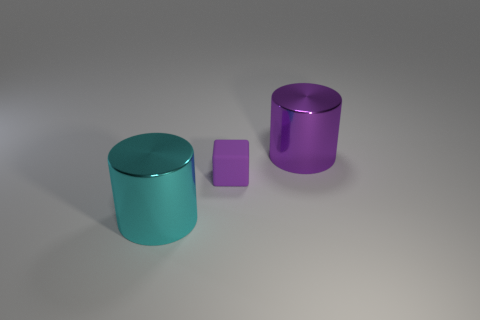Is there anything else that has the same material as the block?
Offer a very short reply. No. Is there any other thing that has the same size as the purple cylinder?
Ensure brevity in your answer.  Yes. What shape is the object that is behind the purple object that is in front of the metal cylinder that is behind the tiny rubber thing?
Your answer should be compact. Cylinder. What is the shape of the large purple metal object behind the big cylinder that is on the left side of the purple block?
Your answer should be compact. Cylinder. There is a purple shiny object; how many tiny purple rubber objects are behind it?
Give a very brief answer. 0. Is there a cyan thing that has the same material as the big cyan cylinder?
Make the answer very short. No. What is the material of the thing that is the same size as the purple cylinder?
Provide a short and direct response. Metal. There is a thing that is both in front of the purple shiny thing and right of the cyan cylinder; what size is it?
Provide a short and direct response. Small. Is the number of tiny blocks that are on the left side of the cyan metal thing less than the number of large purple objects that are on the left side of the rubber object?
Provide a succinct answer. No. What number of purple metal things have the same shape as the cyan metallic thing?
Keep it short and to the point. 1. 